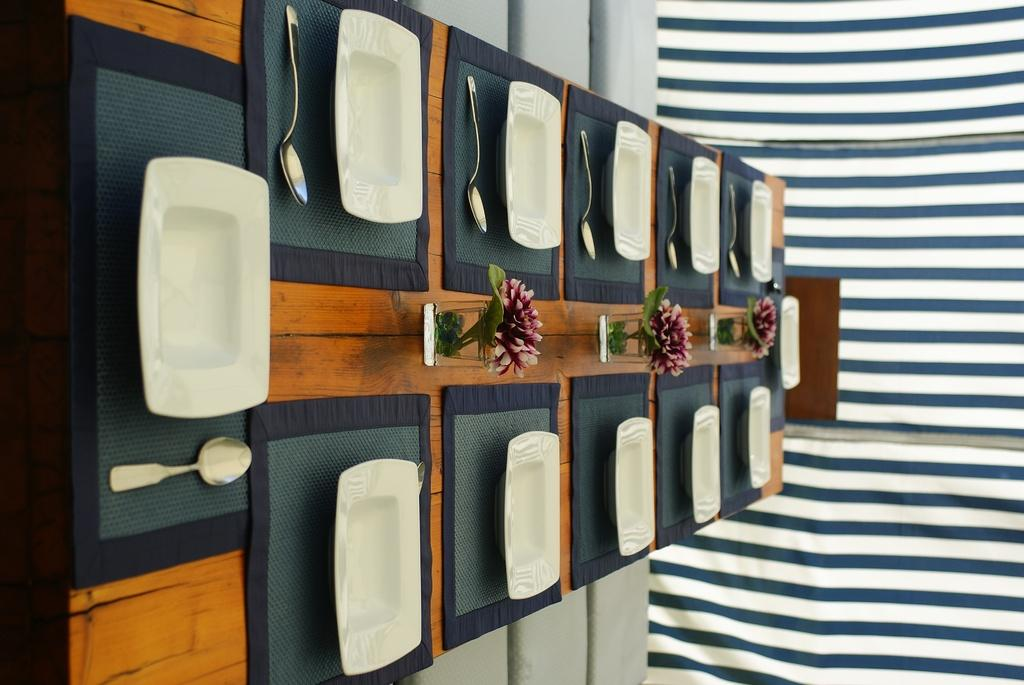What type of furniture is present in the image? There is a dining table in the image. What items are placed on the table? There are plates, spoons, and glasses on the table. What can be seen in the background of the image? There are curtains in the background of the image. What type of wire is holding up the dad in the image? There is no dad or wire present in the image. 